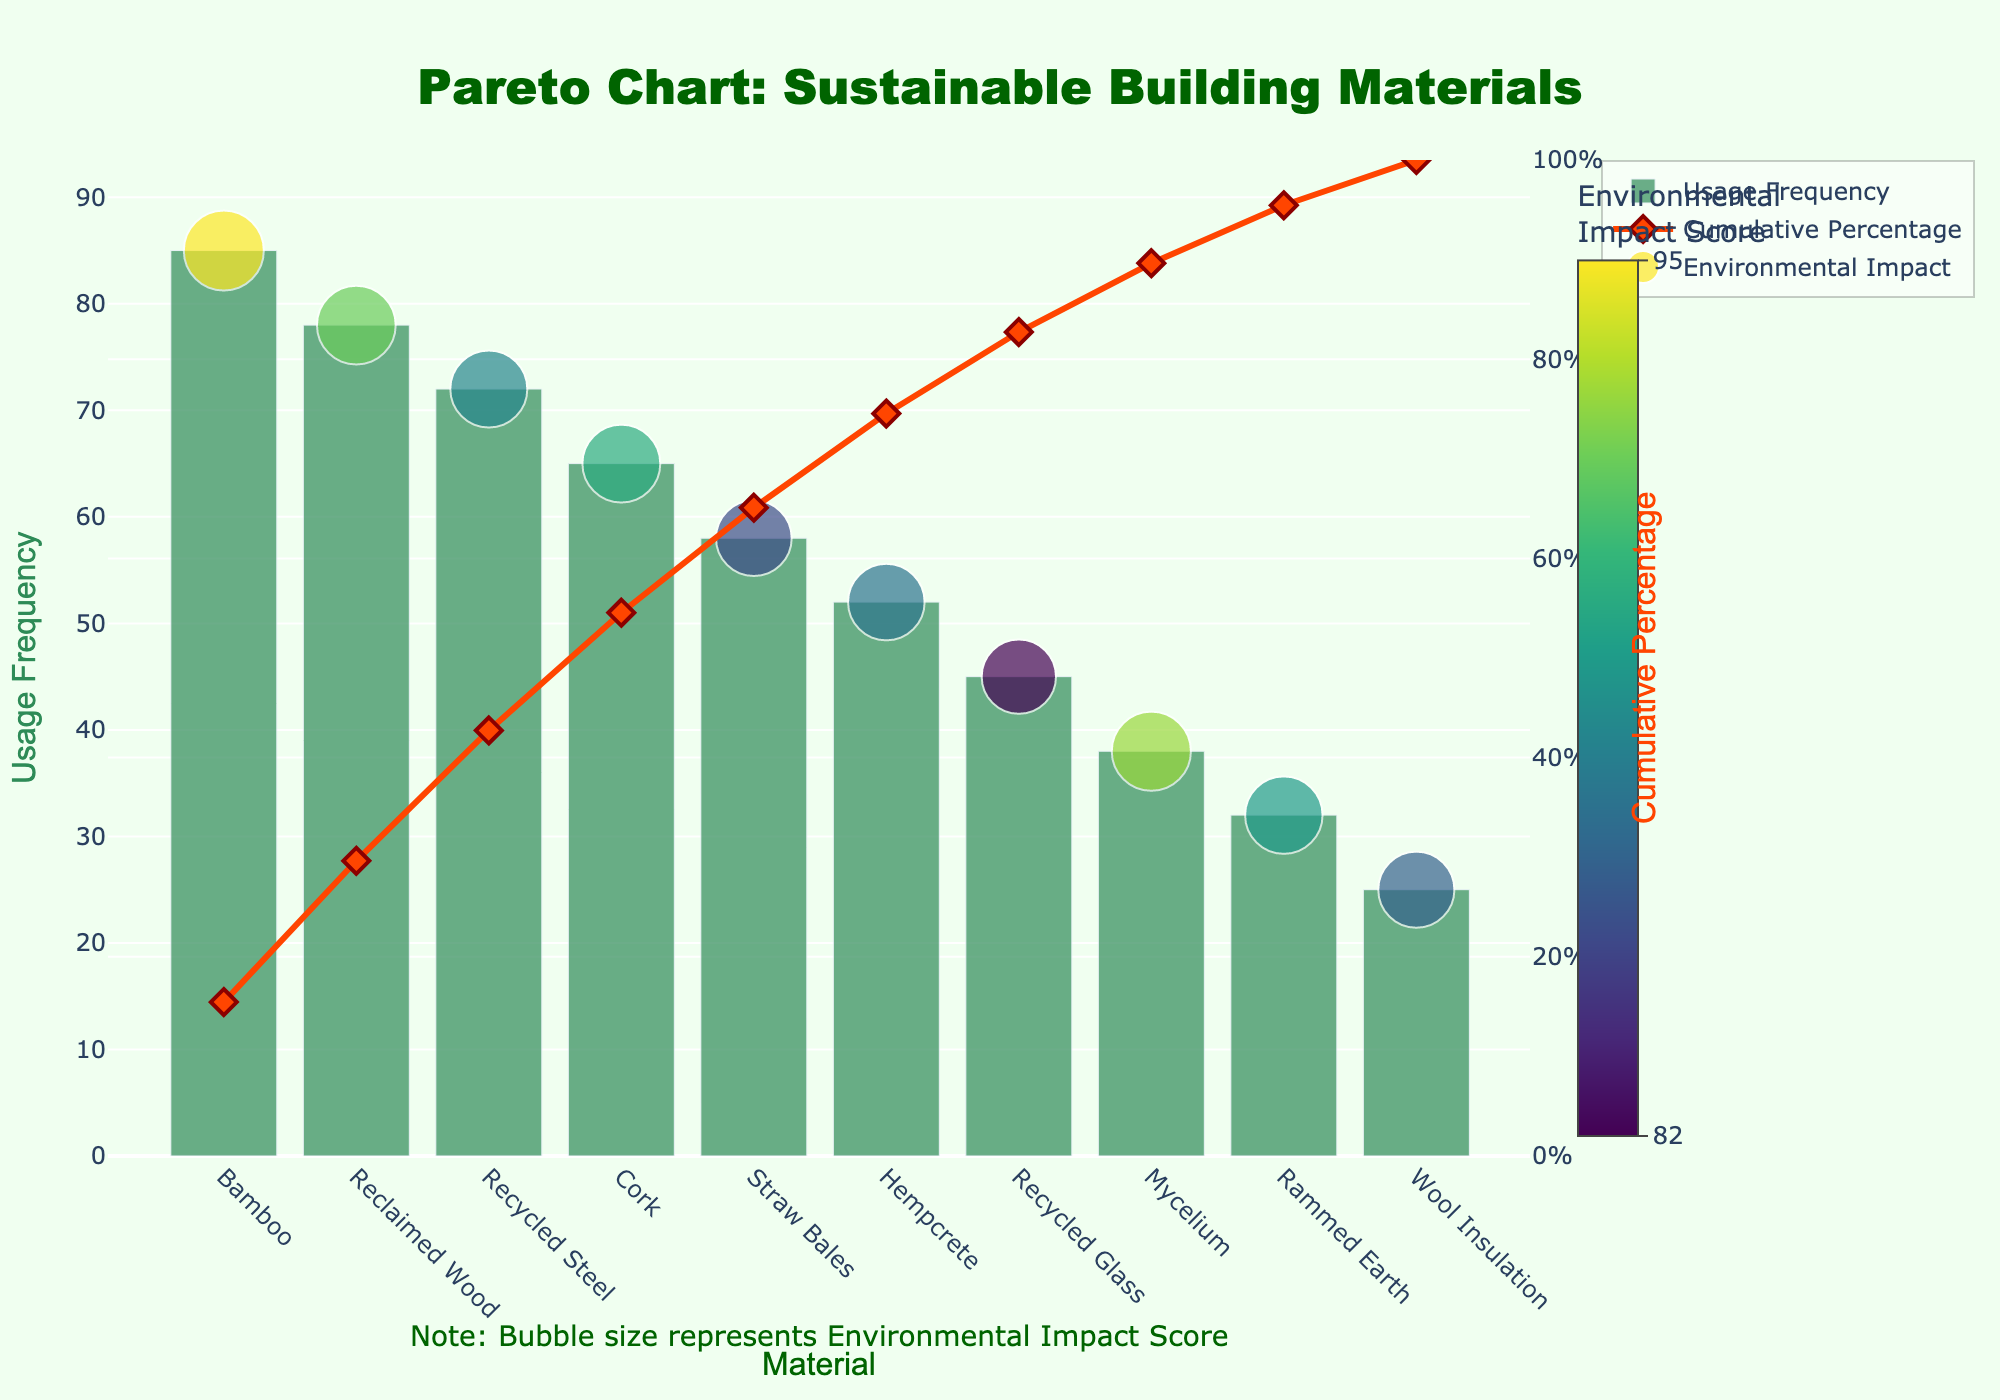what does the usage frequency axis represent? The usage frequency axis represents how often each sustainable building material is used in residential projects. A higher value indicates more frequent usage.
Answer: Usage frequency in residential projects how many materials are represented in the chart? Count the number of distinct materials listed along the x-axis.
Answer: 10 which material has the highest environmental impact score? Identify which material has the largest bubble size and the highest value on the color gradient scale.
Answer: Bamboo how does the cumulative percentage change across the materials? Observe how the cumulative percentage rises as we move from left to right across the materials on the x-axis. It starts at 0% and increases to 100%.
Answer: It increases steadily which material shows up last in terms of cumulative percentage? Look at the last point on the cumulative percentage line on the right side of the chart.
Answer: Wool Insulation compare the usage frequency between bamboo and recycled steel. Check the heights of the bars corresponding to Bamboo and Recycled Steel, and compare their values.
Answer: Bamboo has higher usage frequency what percentage of usage frequency is covered by bamboo and reclaimed wood combined? Add the usage frequencies of Bamboo (85) and Reclaimed Wood (78), then divide by the total usage frequency sum (485), and multiply by 100.
Answer: 33.6% which material with a high environmental impact score also has a lower usage frequency? Look for materials with large bubbles and high color values but shorter bar heights.
Answer: Mycelium what cumulative percentage do we reach with the top three materials? Sum the usage frequencies of the top three materials (Bamboo, Reclaimed Wood, Recycled Steel), calculate their cumulative percentage of the total usage frequency (485).
Answer: 49.2% is there any material with higher environmental impact but lower usage frequency than cork? Compare Cork's bubble size and position with materials placed to the right of Cork with larger bubble sizes.
Answer: Mycelium 